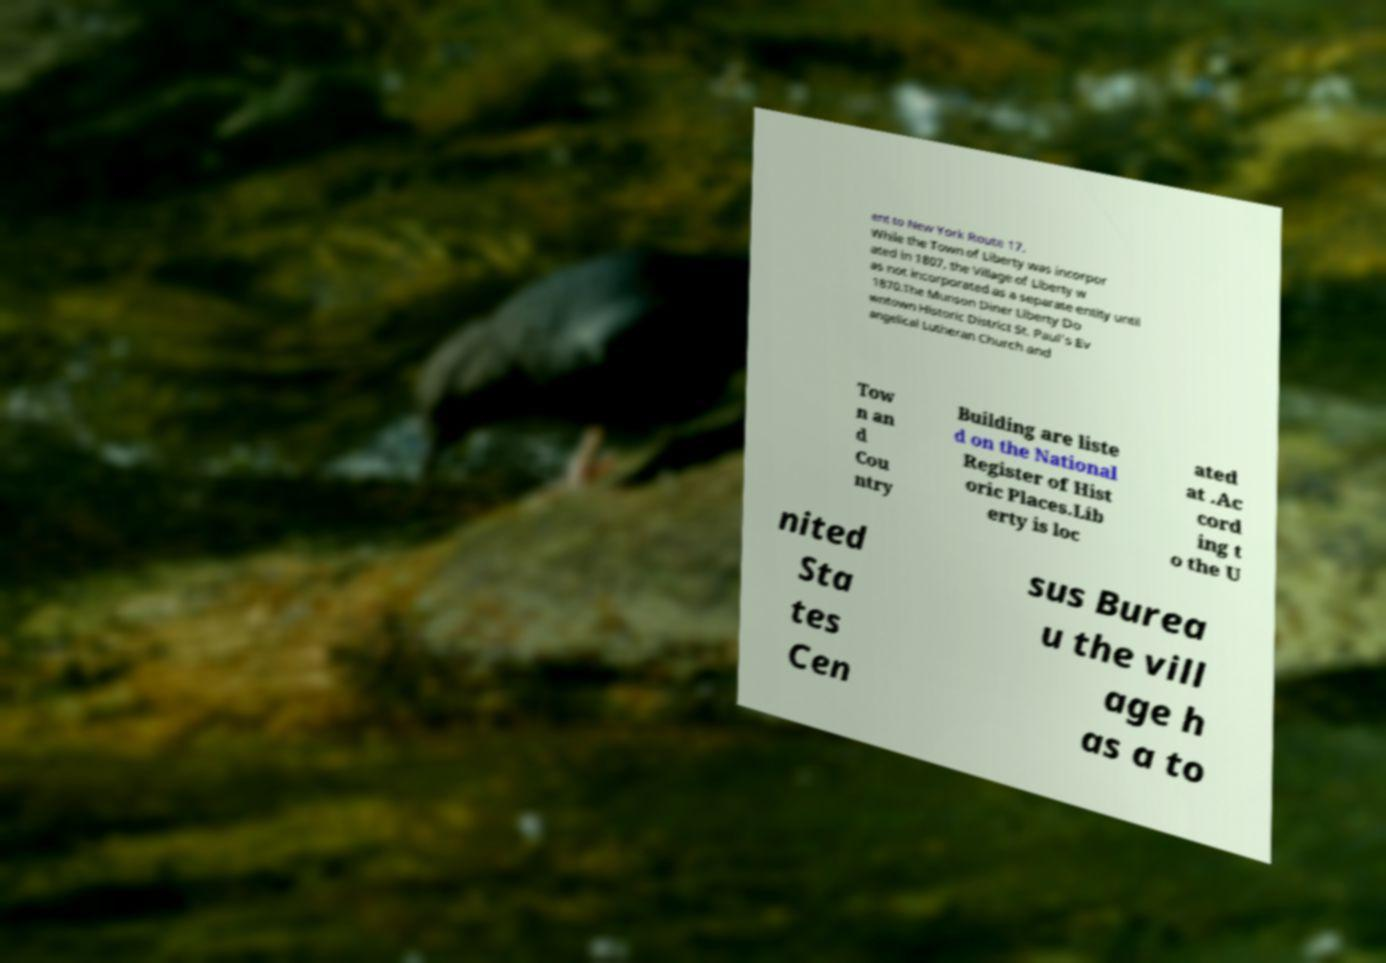Could you extract and type out the text from this image? ent to New York Route 17. While the Town of Liberty was incorpor ated in 1807, the Village of Liberty w as not incorporated as a separate entity until 1870.The Munson Diner Liberty Do wntown Historic District St. Paul's Ev angelical Lutheran Church and Tow n an d Cou ntry Building are liste d on the National Register of Hist oric Places.Lib erty is loc ated at .Ac cord ing t o the U nited Sta tes Cen sus Burea u the vill age h as a to 